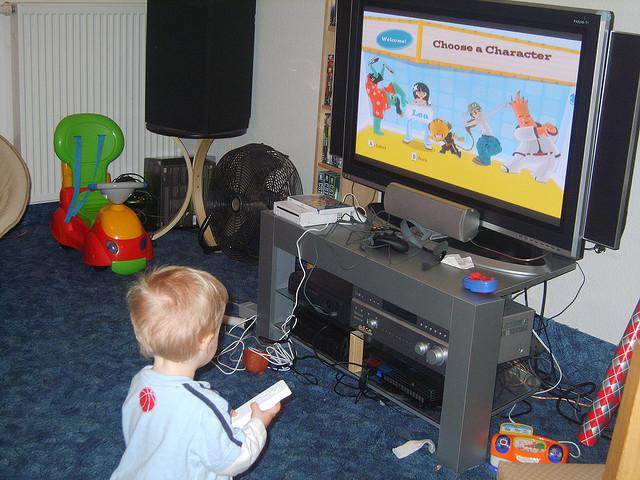Which character has been selected? Please explain your reasoning. second. The child is choosing the second character. 